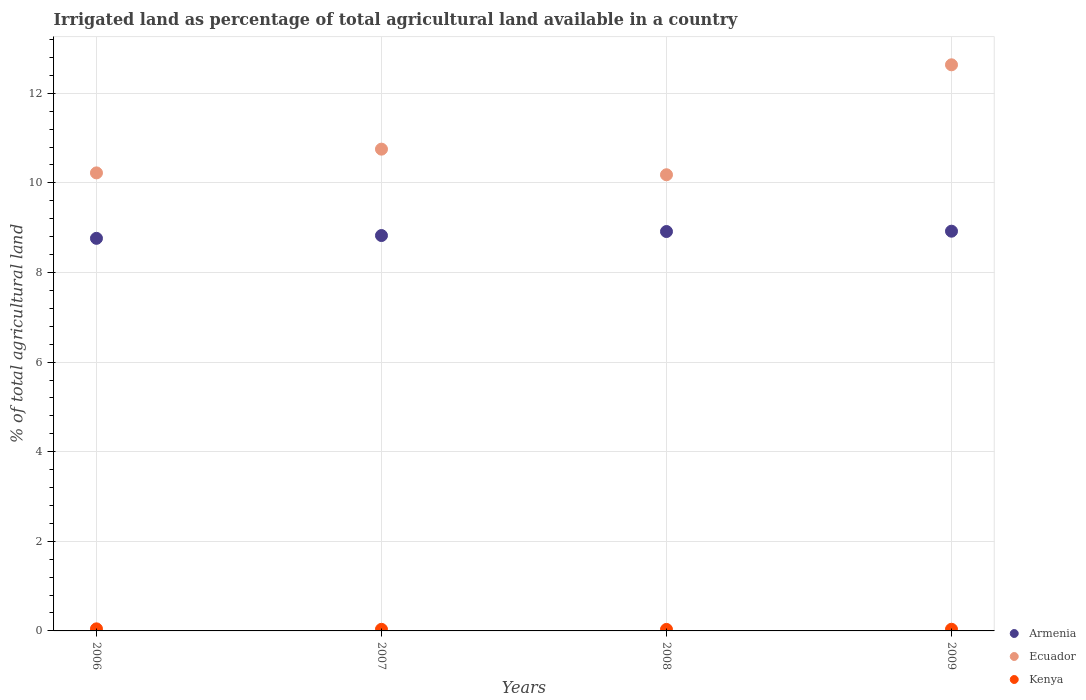Is the number of dotlines equal to the number of legend labels?
Keep it short and to the point. Yes. What is the percentage of irrigated land in Armenia in 2009?
Your response must be concise. 8.92. Across all years, what is the maximum percentage of irrigated land in Ecuador?
Make the answer very short. 12.64. Across all years, what is the minimum percentage of irrigated land in Armenia?
Offer a very short reply. 8.76. In which year was the percentage of irrigated land in Kenya maximum?
Your answer should be compact. 2006. In which year was the percentage of irrigated land in Kenya minimum?
Ensure brevity in your answer.  2008. What is the total percentage of irrigated land in Ecuador in the graph?
Provide a short and direct response. 43.79. What is the difference between the percentage of irrigated land in Armenia in 2006 and that in 2008?
Provide a short and direct response. -0.15. What is the difference between the percentage of irrigated land in Kenya in 2007 and the percentage of irrigated land in Armenia in 2009?
Offer a terse response. -8.89. What is the average percentage of irrigated land in Armenia per year?
Your response must be concise. 8.86. In the year 2009, what is the difference between the percentage of irrigated land in Ecuador and percentage of irrigated land in Armenia?
Provide a short and direct response. 3.71. In how many years, is the percentage of irrigated land in Ecuador greater than 6.8 %?
Provide a succinct answer. 4. What is the ratio of the percentage of irrigated land in Ecuador in 2008 to that in 2009?
Offer a terse response. 0.81. What is the difference between the highest and the second highest percentage of irrigated land in Armenia?
Make the answer very short. 0.01. What is the difference between the highest and the lowest percentage of irrigated land in Kenya?
Offer a very short reply. 0.01. Is the sum of the percentage of irrigated land in Ecuador in 2007 and 2009 greater than the maximum percentage of irrigated land in Kenya across all years?
Provide a short and direct response. Yes. Does the percentage of irrigated land in Ecuador monotonically increase over the years?
Your answer should be compact. No. Is the percentage of irrigated land in Ecuador strictly less than the percentage of irrigated land in Armenia over the years?
Provide a short and direct response. No. Does the graph contain any zero values?
Ensure brevity in your answer.  No. How many legend labels are there?
Keep it short and to the point. 3. How are the legend labels stacked?
Provide a short and direct response. Vertical. What is the title of the graph?
Offer a terse response. Irrigated land as percentage of total agricultural land available in a country. What is the label or title of the Y-axis?
Provide a short and direct response. % of total agricultural land. What is the % of total agricultural land in Armenia in 2006?
Ensure brevity in your answer.  8.76. What is the % of total agricultural land of Ecuador in 2006?
Offer a terse response. 10.22. What is the % of total agricultural land in Kenya in 2006?
Keep it short and to the point. 0.05. What is the % of total agricultural land of Armenia in 2007?
Make the answer very short. 8.82. What is the % of total agricultural land of Ecuador in 2007?
Give a very brief answer. 10.75. What is the % of total agricultural land of Kenya in 2007?
Ensure brevity in your answer.  0.04. What is the % of total agricultural land in Armenia in 2008?
Ensure brevity in your answer.  8.91. What is the % of total agricultural land in Ecuador in 2008?
Offer a very short reply. 10.18. What is the % of total agricultural land in Kenya in 2008?
Make the answer very short. 0.03. What is the % of total agricultural land of Armenia in 2009?
Your response must be concise. 8.92. What is the % of total agricultural land of Ecuador in 2009?
Ensure brevity in your answer.  12.64. What is the % of total agricultural land in Kenya in 2009?
Make the answer very short. 0.04. Across all years, what is the maximum % of total agricultural land of Armenia?
Your response must be concise. 8.92. Across all years, what is the maximum % of total agricultural land of Ecuador?
Offer a terse response. 12.64. Across all years, what is the maximum % of total agricultural land of Kenya?
Give a very brief answer. 0.05. Across all years, what is the minimum % of total agricultural land of Armenia?
Make the answer very short. 8.76. Across all years, what is the minimum % of total agricultural land of Ecuador?
Your response must be concise. 10.18. Across all years, what is the minimum % of total agricultural land of Kenya?
Ensure brevity in your answer.  0.03. What is the total % of total agricultural land of Armenia in the graph?
Your response must be concise. 35.42. What is the total % of total agricultural land of Ecuador in the graph?
Give a very brief answer. 43.79. What is the total % of total agricultural land of Kenya in the graph?
Your response must be concise. 0.15. What is the difference between the % of total agricultural land in Armenia in 2006 and that in 2007?
Your response must be concise. -0.06. What is the difference between the % of total agricultural land in Ecuador in 2006 and that in 2007?
Make the answer very short. -0.53. What is the difference between the % of total agricultural land of Kenya in 2006 and that in 2007?
Your answer should be very brief. 0.01. What is the difference between the % of total agricultural land in Armenia in 2006 and that in 2008?
Your response must be concise. -0.15. What is the difference between the % of total agricultural land in Ecuador in 2006 and that in 2008?
Ensure brevity in your answer.  0.04. What is the difference between the % of total agricultural land in Kenya in 2006 and that in 2008?
Make the answer very short. 0.01. What is the difference between the % of total agricultural land of Armenia in 2006 and that in 2009?
Make the answer very short. -0.16. What is the difference between the % of total agricultural land in Ecuador in 2006 and that in 2009?
Give a very brief answer. -2.41. What is the difference between the % of total agricultural land of Kenya in 2006 and that in 2009?
Your answer should be very brief. 0.01. What is the difference between the % of total agricultural land of Armenia in 2007 and that in 2008?
Keep it short and to the point. -0.09. What is the difference between the % of total agricultural land of Ecuador in 2007 and that in 2008?
Provide a succinct answer. 0.57. What is the difference between the % of total agricultural land of Kenya in 2007 and that in 2008?
Give a very brief answer. 0. What is the difference between the % of total agricultural land in Armenia in 2007 and that in 2009?
Offer a terse response. -0.1. What is the difference between the % of total agricultural land of Ecuador in 2007 and that in 2009?
Provide a short and direct response. -1.88. What is the difference between the % of total agricultural land in Kenya in 2007 and that in 2009?
Your answer should be compact. -0. What is the difference between the % of total agricultural land of Armenia in 2008 and that in 2009?
Make the answer very short. -0.01. What is the difference between the % of total agricultural land of Ecuador in 2008 and that in 2009?
Give a very brief answer. -2.45. What is the difference between the % of total agricultural land of Kenya in 2008 and that in 2009?
Your response must be concise. -0. What is the difference between the % of total agricultural land in Armenia in 2006 and the % of total agricultural land in Ecuador in 2007?
Offer a terse response. -1.99. What is the difference between the % of total agricultural land of Armenia in 2006 and the % of total agricultural land of Kenya in 2007?
Offer a very short reply. 8.73. What is the difference between the % of total agricultural land of Ecuador in 2006 and the % of total agricultural land of Kenya in 2007?
Offer a very short reply. 10.19. What is the difference between the % of total agricultural land of Armenia in 2006 and the % of total agricultural land of Ecuador in 2008?
Offer a terse response. -1.42. What is the difference between the % of total agricultural land in Armenia in 2006 and the % of total agricultural land in Kenya in 2008?
Make the answer very short. 8.73. What is the difference between the % of total agricultural land of Ecuador in 2006 and the % of total agricultural land of Kenya in 2008?
Your response must be concise. 10.19. What is the difference between the % of total agricultural land in Armenia in 2006 and the % of total agricultural land in Ecuador in 2009?
Provide a succinct answer. -3.87. What is the difference between the % of total agricultural land of Armenia in 2006 and the % of total agricultural land of Kenya in 2009?
Offer a very short reply. 8.73. What is the difference between the % of total agricultural land of Ecuador in 2006 and the % of total agricultural land of Kenya in 2009?
Provide a succinct answer. 10.19. What is the difference between the % of total agricultural land of Armenia in 2007 and the % of total agricultural land of Ecuador in 2008?
Your response must be concise. -1.36. What is the difference between the % of total agricultural land of Armenia in 2007 and the % of total agricultural land of Kenya in 2008?
Provide a succinct answer. 8.79. What is the difference between the % of total agricultural land in Ecuador in 2007 and the % of total agricultural land in Kenya in 2008?
Offer a very short reply. 10.72. What is the difference between the % of total agricultural land of Armenia in 2007 and the % of total agricultural land of Ecuador in 2009?
Keep it short and to the point. -3.81. What is the difference between the % of total agricultural land of Armenia in 2007 and the % of total agricultural land of Kenya in 2009?
Provide a short and direct response. 8.79. What is the difference between the % of total agricultural land of Ecuador in 2007 and the % of total agricultural land of Kenya in 2009?
Your answer should be very brief. 10.72. What is the difference between the % of total agricultural land in Armenia in 2008 and the % of total agricultural land in Ecuador in 2009?
Make the answer very short. -3.72. What is the difference between the % of total agricultural land in Armenia in 2008 and the % of total agricultural land in Kenya in 2009?
Your answer should be compact. 8.88. What is the difference between the % of total agricultural land of Ecuador in 2008 and the % of total agricultural land of Kenya in 2009?
Your response must be concise. 10.14. What is the average % of total agricultural land in Armenia per year?
Keep it short and to the point. 8.86. What is the average % of total agricultural land of Ecuador per year?
Your response must be concise. 10.95. What is the average % of total agricultural land in Kenya per year?
Ensure brevity in your answer.  0.04. In the year 2006, what is the difference between the % of total agricultural land in Armenia and % of total agricultural land in Ecuador?
Your response must be concise. -1.46. In the year 2006, what is the difference between the % of total agricultural land in Armenia and % of total agricultural land in Kenya?
Your answer should be compact. 8.72. In the year 2006, what is the difference between the % of total agricultural land in Ecuador and % of total agricultural land in Kenya?
Provide a short and direct response. 10.18. In the year 2007, what is the difference between the % of total agricultural land in Armenia and % of total agricultural land in Ecuador?
Give a very brief answer. -1.93. In the year 2007, what is the difference between the % of total agricultural land of Armenia and % of total agricultural land of Kenya?
Provide a short and direct response. 8.79. In the year 2007, what is the difference between the % of total agricultural land of Ecuador and % of total agricultural land of Kenya?
Provide a succinct answer. 10.72. In the year 2008, what is the difference between the % of total agricultural land of Armenia and % of total agricultural land of Ecuador?
Your response must be concise. -1.27. In the year 2008, what is the difference between the % of total agricultural land in Armenia and % of total agricultural land in Kenya?
Offer a very short reply. 8.88. In the year 2008, what is the difference between the % of total agricultural land of Ecuador and % of total agricultural land of Kenya?
Offer a very short reply. 10.15. In the year 2009, what is the difference between the % of total agricultural land in Armenia and % of total agricultural land in Ecuador?
Offer a very short reply. -3.71. In the year 2009, what is the difference between the % of total agricultural land in Armenia and % of total agricultural land in Kenya?
Provide a short and direct response. 8.88. In the year 2009, what is the difference between the % of total agricultural land in Ecuador and % of total agricultural land in Kenya?
Give a very brief answer. 12.6. What is the ratio of the % of total agricultural land of Armenia in 2006 to that in 2007?
Your answer should be compact. 0.99. What is the ratio of the % of total agricultural land in Ecuador in 2006 to that in 2007?
Give a very brief answer. 0.95. What is the ratio of the % of total agricultural land in Kenya in 2006 to that in 2007?
Keep it short and to the point. 1.3. What is the ratio of the % of total agricultural land in Armenia in 2006 to that in 2008?
Offer a terse response. 0.98. What is the ratio of the % of total agricultural land of Kenya in 2006 to that in 2008?
Your response must be concise. 1.38. What is the ratio of the % of total agricultural land of Armenia in 2006 to that in 2009?
Provide a succinct answer. 0.98. What is the ratio of the % of total agricultural land of Ecuador in 2006 to that in 2009?
Offer a terse response. 0.81. What is the ratio of the % of total agricultural land of Kenya in 2006 to that in 2009?
Offer a terse response. 1.25. What is the ratio of the % of total agricultural land in Ecuador in 2007 to that in 2008?
Provide a short and direct response. 1.06. What is the ratio of the % of total agricultural land in Kenya in 2007 to that in 2008?
Keep it short and to the point. 1.06. What is the ratio of the % of total agricultural land of Armenia in 2007 to that in 2009?
Provide a succinct answer. 0.99. What is the ratio of the % of total agricultural land in Ecuador in 2007 to that in 2009?
Your answer should be compact. 0.85. What is the ratio of the % of total agricultural land in Kenya in 2007 to that in 2009?
Keep it short and to the point. 0.96. What is the ratio of the % of total agricultural land in Armenia in 2008 to that in 2009?
Your answer should be very brief. 1. What is the ratio of the % of total agricultural land in Ecuador in 2008 to that in 2009?
Give a very brief answer. 0.81. What is the ratio of the % of total agricultural land in Kenya in 2008 to that in 2009?
Your answer should be very brief. 0.91. What is the difference between the highest and the second highest % of total agricultural land in Armenia?
Your response must be concise. 0.01. What is the difference between the highest and the second highest % of total agricultural land of Ecuador?
Make the answer very short. 1.88. What is the difference between the highest and the second highest % of total agricultural land in Kenya?
Your answer should be very brief. 0.01. What is the difference between the highest and the lowest % of total agricultural land in Armenia?
Provide a succinct answer. 0.16. What is the difference between the highest and the lowest % of total agricultural land in Ecuador?
Provide a short and direct response. 2.45. What is the difference between the highest and the lowest % of total agricultural land in Kenya?
Your answer should be compact. 0.01. 